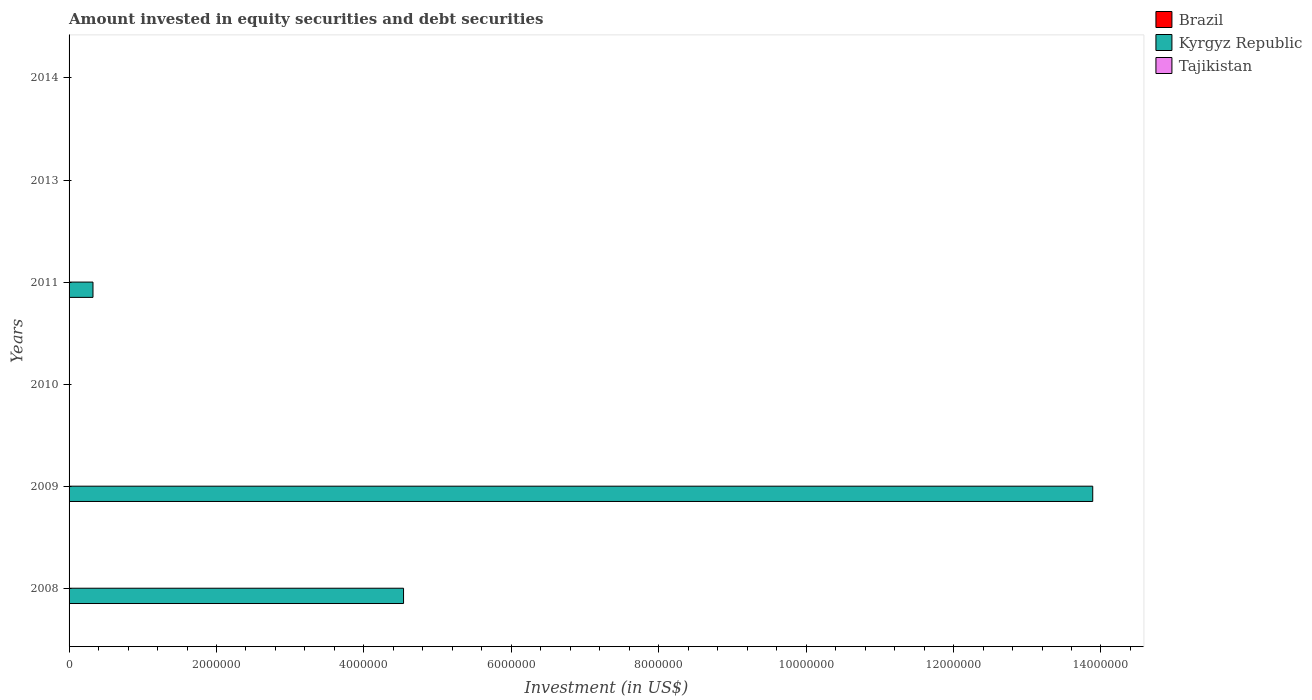How many different coloured bars are there?
Provide a succinct answer. 1. Are the number of bars per tick equal to the number of legend labels?
Keep it short and to the point. No. How many bars are there on the 3rd tick from the bottom?
Your answer should be compact. 0. What is the label of the 4th group of bars from the top?
Your answer should be very brief. 2010. In how many cases, is the number of bars for a given year not equal to the number of legend labels?
Offer a terse response. 6. What is the amount invested in equity securities and debt securities in Kyrgyz Republic in 2010?
Ensure brevity in your answer.  0. Across all years, what is the maximum amount invested in equity securities and debt securities in Kyrgyz Republic?
Your answer should be compact. 1.39e+07. Across all years, what is the minimum amount invested in equity securities and debt securities in Tajikistan?
Provide a succinct answer. 0. What is the difference between the amount invested in equity securities and debt securities in Kyrgyz Republic in 2008 and that in 2009?
Offer a very short reply. -9.35e+06. What is the difference between the amount invested in equity securities and debt securities in Brazil in 2009 and the amount invested in equity securities and debt securities in Kyrgyz Republic in 2008?
Ensure brevity in your answer.  -4.54e+06. What is the average amount invested in equity securities and debt securities in Tajikistan per year?
Keep it short and to the point. 0. What is the ratio of the amount invested in equity securities and debt securities in Kyrgyz Republic in 2009 to that in 2011?
Your response must be concise. 42.8. What is the difference between the highest and the second highest amount invested in equity securities and debt securities in Kyrgyz Republic?
Give a very brief answer. 9.35e+06. What is the difference between the highest and the lowest amount invested in equity securities and debt securities in Kyrgyz Republic?
Your response must be concise. 1.39e+07. In how many years, is the amount invested in equity securities and debt securities in Kyrgyz Republic greater than the average amount invested in equity securities and debt securities in Kyrgyz Republic taken over all years?
Make the answer very short. 2. Is the sum of the amount invested in equity securities and debt securities in Kyrgyz Republic in 2008 and 2009 greater than the maximum amount invested in equity securities and debt securities in Tajikistan across all years?
Provide a short and direct response. Yes. What is the difference between two consecutive major ticks on the X-axis?
Your answer should be compact. 2.00e+06. Does the graph contain any zero values?
Provide a succinct answer. Yes. Does the graph contain grids?
Ensure brevity in your answer.  No. How many legend labels are there?
Keep it short and to the point. 3. What is the title of the graph?
Offer a very short reply. Amount invested in equity securities and debt securities. What is the label or title of the X-axis?
Provide a short and direct response. Investment (in US$). What is the Investment (in US$) of Kyrgyz Republic in 2008?
Make the answer very short. 4.54e+06. What is the Investment (in US$) of Tajikistan in 2008?
Provide a short and direct response. 0. What is the Investment (in US$) of Kyrgyz Republic in 2009?
Provide a short and direct response. 1.39e+07. What is the Investment (in US$) of Tajikistan in 2009?
Your response must be concise. 0. What is the Investment (in US$) of Brazil in 2010?
Your answer should be compact. 0. What is the Investment (in US$) in Tajikistan in 2010?
Offer a terse response. 0. What is the Investment (in US$) in Brazil in 2011?
Offer a terse response. 0. What is the Investment (in US$) in Kyrgyz Republic in 2011?
Your answer should be compact. 3.24e+05. What is the Investment (in US$) in Brazil in 2013?
Your response must be concise. 0. What is the Investment (in US$) in Kyrgyz Republic in 2013?
Provide a succinct answer. 0. What is the Investment (in US$) in Tajikistan in 2013?
Offer a very short reply. 0. Across all years, what is the maximum Investment (in US$) in Kyrgyz Republic?
Your answer should be very brief. 1.39e+07. What is the total Investment (in US$) in Kyrgyz Republic in the graph?
Your answer should be very brief. 1.88e+07. What is the total Investment (in US$) in Tajikistan in the graph?
Make the answer very short. 0. What is the difference between the Investment (in US$) of Kyrgyz Republic in 2008 and that in 2009?
Your answer should be compact. -9.35e+06. What is the difference between the Investment (in US$) in Kyrgyz Republic in 2008 and that in 2011?
Your answer should be very brief. 4.21e+06. What is the difference between the Investment (in US$) in Kyrgyz Republic in 2009 and that in 2011?
Provide a succinct answer. 1.36e+07. What is the average Investment (in US$) of Brazil per year?
Give a very brief answer. 0. What is the average Investment (in US$) in Kyrgyz Republic per year?
Offer a terse response. 3.13e+06. What is the average Investment (in US$) of Tajikistan per year?
Give a very brief answer. 0. What is the ratio of the Investment (in US$) of Kyrgyz Republic in 2008 to that in 2009?
Give a very brief answer. 0.33. What is the ratio of the Investment (in US$) of Kyrgyz Republic in 2008 to that in 2011?
Make the answer very short. 13.99. What is the ratio of the Investment (in US$) of Kyrgyz Republic in 2009 to that in 2011?
Your response must be concise. 42.8. What is the difference between the highest and the second highest Investment (in US$) of Kyrgyz Republic?
Your answer should be very brief. 9.35e+06. What is the difference between the highest and the lowest Investment (in US$) in Kyrgyz Republic?
Your answer should be compact. 1.39e+07. 